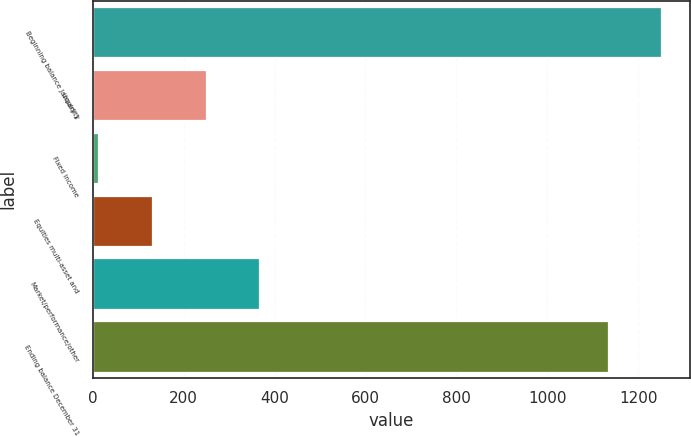<chart> <loc_0><loc_0><loc_500><loc_500><bar_chart><fcel>Beginning balance January 1<fcel>Liquidity<fcel>Fixed income<fcel>Equities multi-asset and<fcel>Market/performance/other<fcel>Ending balance December 31<nl><fcel>1251.1<fcel>248.2<fcel>12<fcel>130.1<fcel>366.3<fcel>1133<nl></chart> 